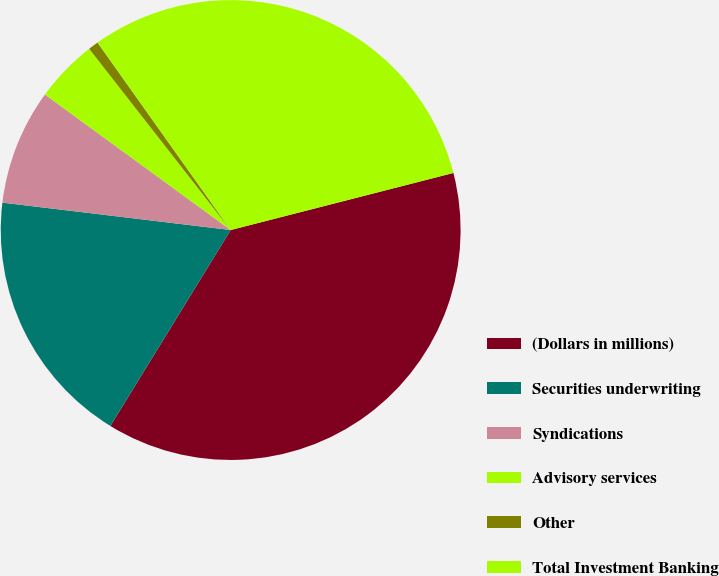Convert chart to OTSL. <chart><loc_0><loc_0><loc_500><loc_500><pie_chart><fcel>(Dollars in millions)<fcel>Securities underwriting<fcel>Syndications<fcel>Advisory services<fcel>Other<fcel>Total Investment Banking<nl><fcel>37.76%<fcel>18.14%<fcel>8.13%<fcel>4.42%<fcel>0.72%<fcel>30.84%<nl></chart> 